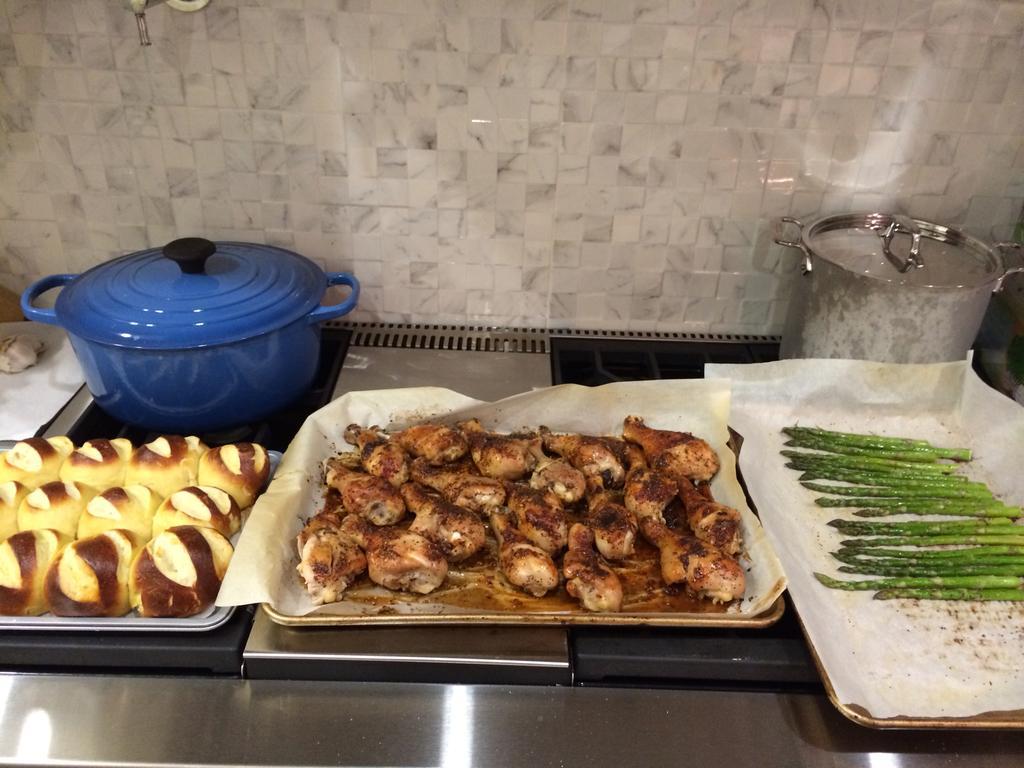Please provide a concise description of this image. In this picture I can observe some food placed on the desk. The food is in brown and green color. On the left side I can observe blue color dish. In the background there is a wall. 